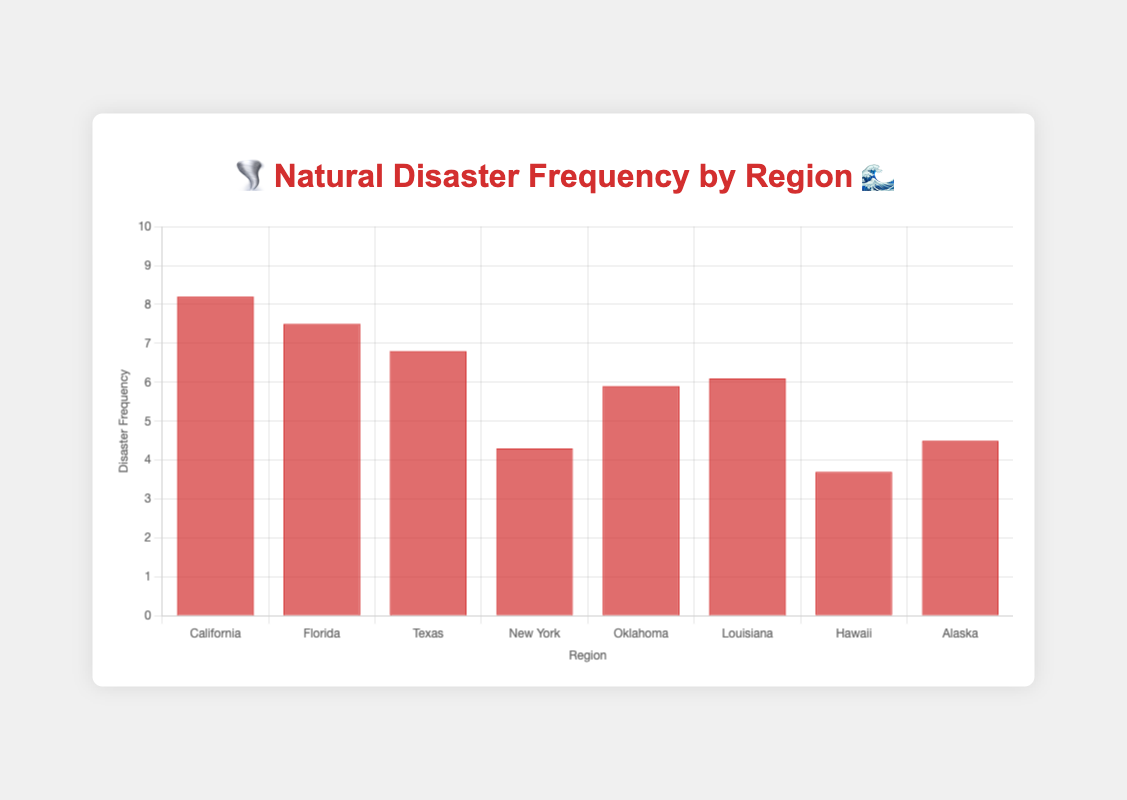what is the title of the chart? The title is typically located at the top of the chart and gives an overall description of what is being visualized. In this case, it is "🌪️ Natural Disaster Frequency by Region 🌊".
Answer: 🌪️ Natural Disaster Frequency by Region 🌊 which region has the highest disaster frequency? By looking at the height of the bars, we can identify California as having the highest disaster frequency with a value of 8.2.
Answer: California how many regions are shown in the chart? Counting the number of bars on the x-axis or the number of region names listed, we can determine there are 8 regions in the chart.
Answer: 8 which regions have the same preparedness level emojis? By examining the preparedness level emojis for each region, we see that California, Florida, and Hawaii all have "🚨🚨🚨🚨".
Answer: California, Florida, Hawaii what is the average disaster frequency of the regions with three preparedness level emojis? The regions with three preparedness level emojis are Texas, New York, and Louisiana. Their frequencies are 6.8, 4.3, and 6.1 respectively. To find the average, add these frequencies together and divide by the number of regions: (6.8 + 4.3 + 6.1) / 3 = 5.73.
Answer: 5.73 what is the difference in disaster frequency between California and Alaska? The disaster frequency for California is 8.2 and for Alaska, it is 4.5. Subtracting Alaska's frequency from California's gives 8.2 - 4.5 = 3.7.
Answer: 3.7 which region has the lowest preparedness level? By identifying the bar with the lowest number of preparedness emojis, we find Oklahoma and Alaska each have the lowest preparedness level of "🚨🚨".
Answer: Oklahoma, Alaska are there any regions with a disaster frequency less than 4? By checking the y-axis values, Hawaii is the only region with a disaster frequency of 3.7, which is less than 4.
Answer: Hawaii compare the preparedness levels of Texas and New York. Which region is better prepared? Texas has a preparedness level of "🚨🚨🚨", while New York also has "🚨🚨🚨". Both regions have the same preparedness level.
Answer: Both regions have the same preparedness level what's the total disaster frequency of all regions combined? Sum the disaster frequencies of all the regions: 8.2 (California) + 7.5 (Florida) + 6.8 (Texas) + 4.3 (New York) + 5.9 (Oklahoma) + 6.1 (Louisiana) + 3.7 (Hawaii) + 4.5 (Alaska) = 46.
Answer: 46 